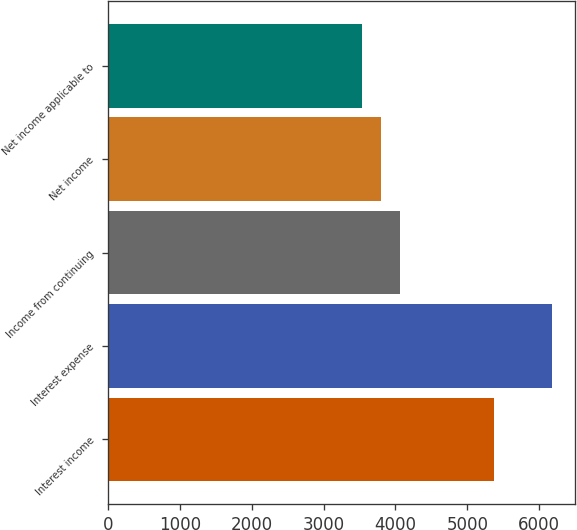<chart> <loc_0><loc_0><loc_500><loc_500><bar_chart><fcel>Interest income<fcel>Interest expense<fcel>Income from continuing<fcel>Net income<fcel>Net income applicable to<nl><fcel>5377<fcel>6186<fcel>4066<fcel>3801<fcel>3536<nl></chart> 